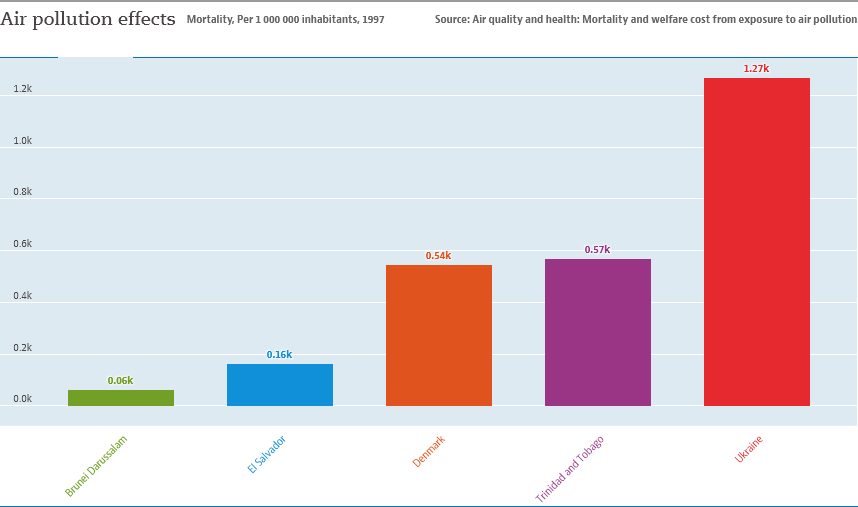List a handful of essential elements in this visual. The second largest bar value in the graph is 0.57. The average of the two smallest bars is 0.11. 